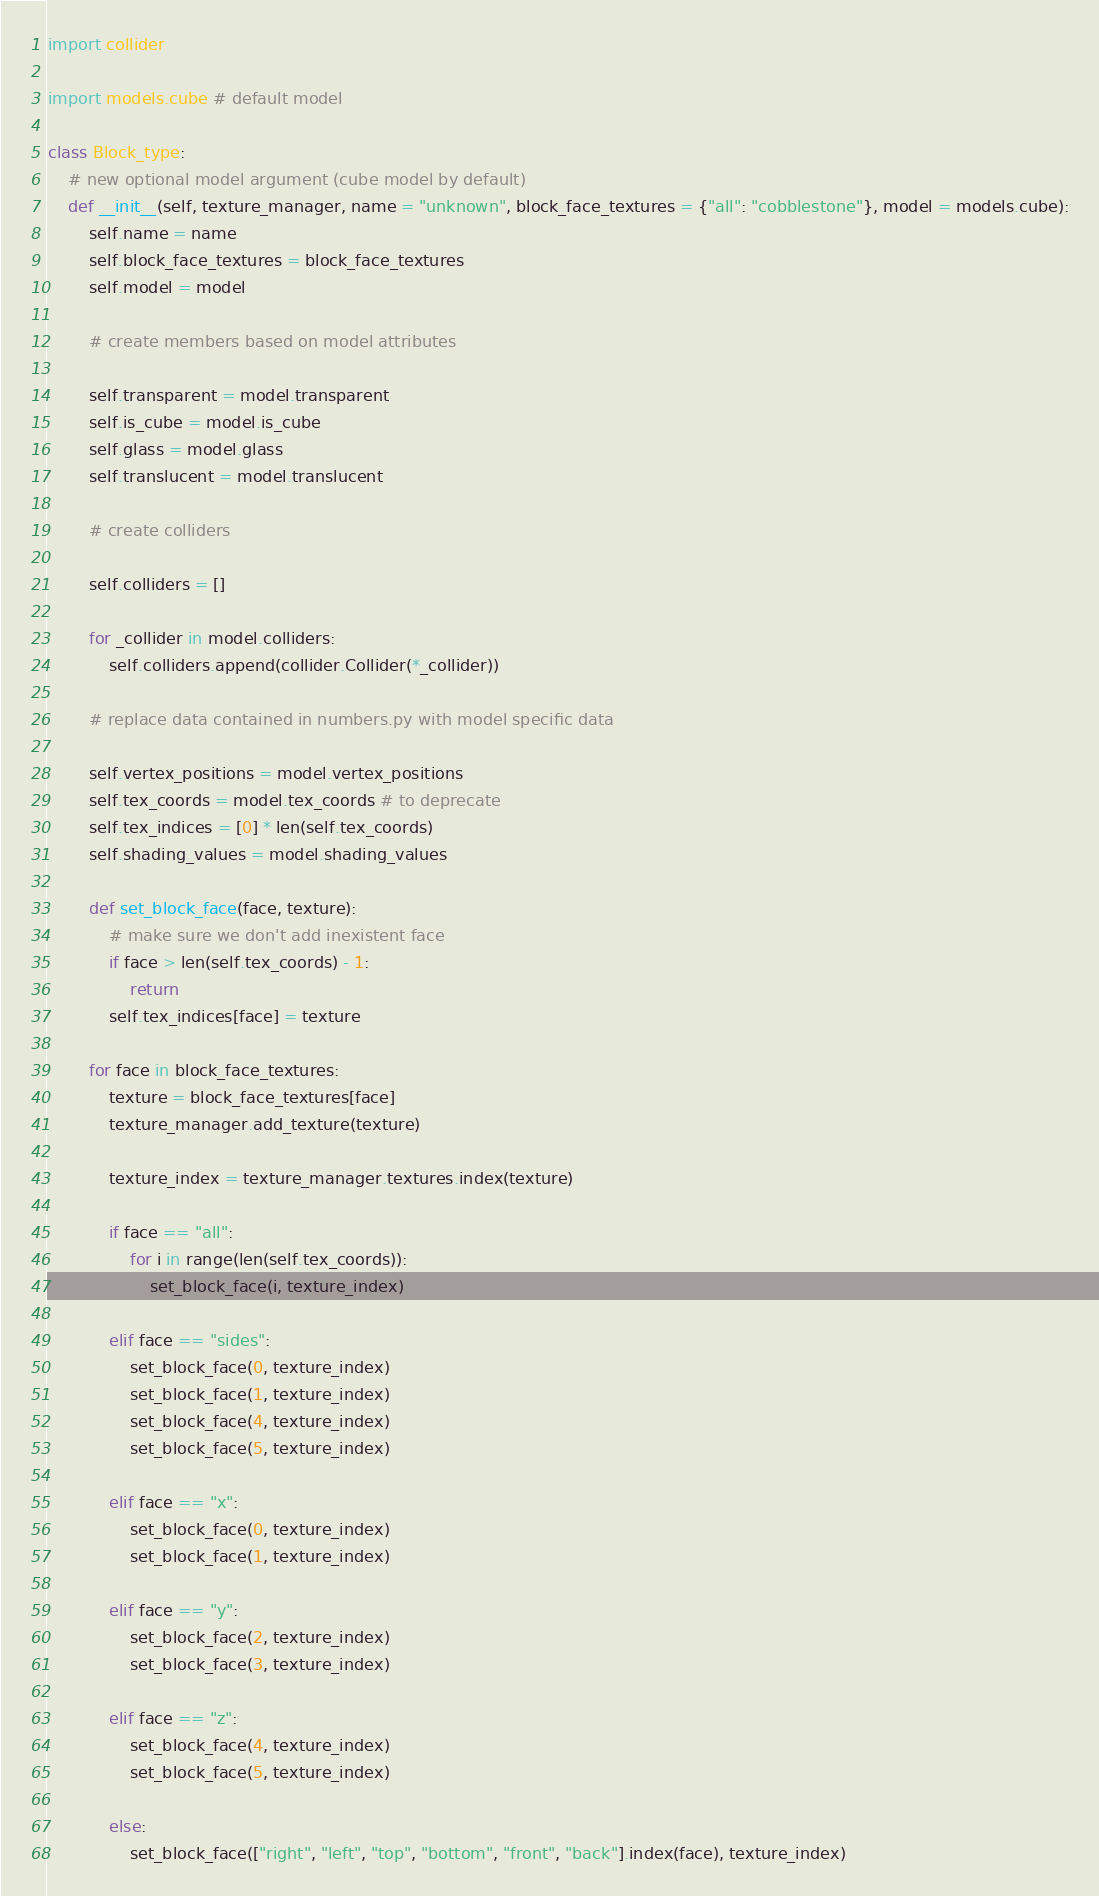Convert code to text. <code><loc_0><loc_0><loc_500><loc_500><_Python_>import collider

import models.cube # default model

class Block_type:
	# new optional model argument (cube model by default)
	def __init__(self, texture_manager, name = "unknown", block_face_textures = {"all": "cobblestone"}, model = models.cube):
		self.name = name
		self.block_face_textures = block_face_textures
		self.model = model

		# create members based on model attributes

		self.transparent = model.transparent
		self.is_cube = model.is_cube
		self.glass = model.glass
		self.translucent = model.translucent

		# create colliders

		self.colliders = []

		for _collider in model.colliders:
			self.colliders.append(collider.Collider(*_collider))

		# replace data contained in numbers.py with model specific data

		self.vertex_positions = model.vertex_positions
		self.tex_coords = model.tex_coords # to deprecate
		self.tex_indices = [0] * len(self.tex_coords)
		self.shading_values = model.shading_values

		def set_block_face(face, texture):
			# make sure we don't add inexistent face
			if face > len(self.tex_coords) - 1:
				return
			self.tex_indices[face] = texture

		for face in block_face_textures:
			texture = block_face_textures[face]
			texture_manager.add_texture(texture)

			texture_index = texture_manager.textures.index(texture)

			if face == "all":
				for i in range(len(self.tex_coords)):
					set_block_face(i, texture_index)
			
			elif face == "sides":
				set_block_face(0, texture_index)
				set_block_face(1, texture_index)
				set_block_face(4, texture_index)
				set_block_face(5, texture_index)
			
			elif face == "x":
				set_block_face(0, texture_index)
				set_block_face(1, texture_index)
			
			elif face == "y":
				set_block_face(2, texture_index)
				set_block_face(3, texture_index)

			elif face == "z":
				set_block_face(4, texture_index)
				set_block_face(5, texture_index)
			
			else:
				set_block_face(["right", "left", "top", "bottom", "front", "back"].index(face), texture_index)</code> 